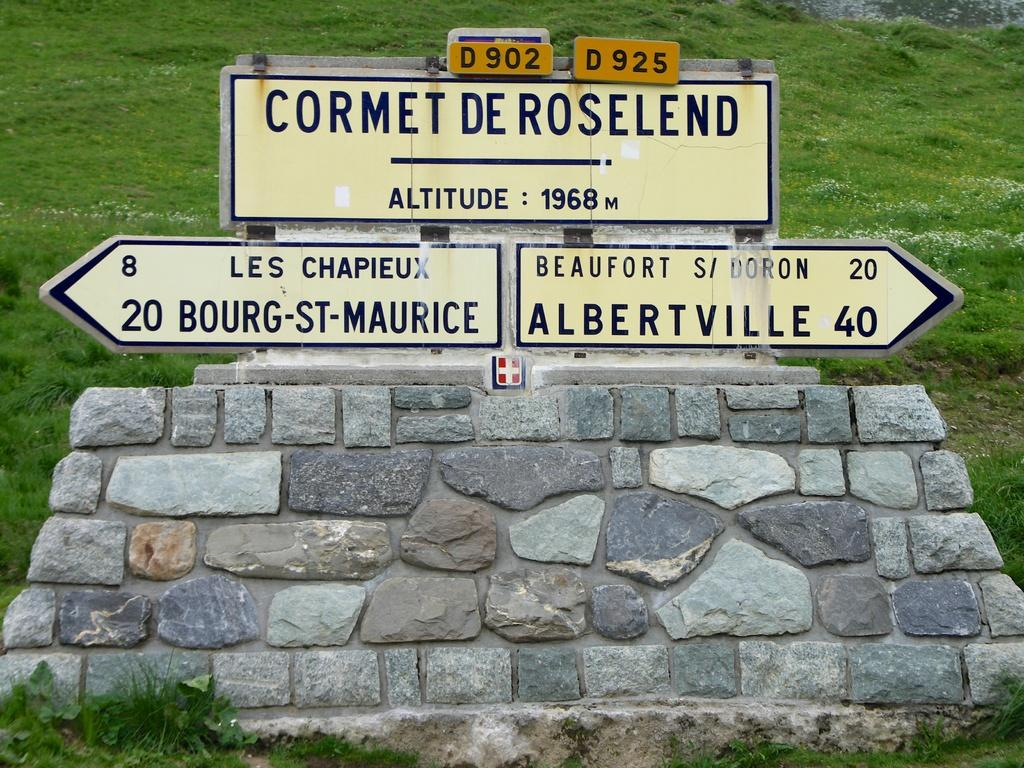Provide a one-sentence caption for the provided image. Cormet de roseland, bourg st maurice, and albertville wrote on top of bricks. 